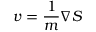Convert formula to latex. <formula><loc_0><loc_0><loc_500><loc_500>v = \frac { 1 } { m } \nabla S</formula> 